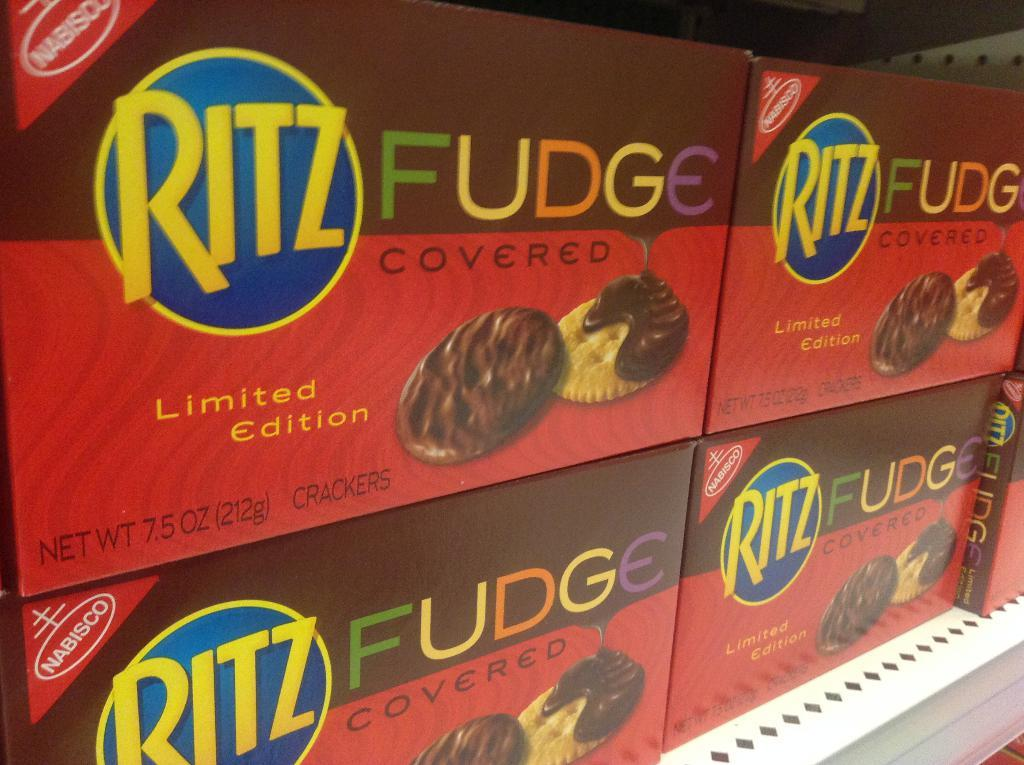What is placed on the table in the image? There are cookies boxes on a table. How are the boxes arranged on the table? The boxes are placed in an order. What color can be seen on some of the boxes? Some boxes are red in color. What is depicted on each box? Each box has images of two cookies. What type of window can be seen in the image? There is no window present in the image; it features cookies boxes on a table. Can you describe the acoustics of the room in the image? The image does not provide any information about the acoustics of the room, as it only shows cookies boxes on a table. 